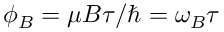Convert formula to latex. <formula><loc_0><loc_0><loc_500><loc_500>\phi _ { B } = \mu B \tau / \hbar { = } \omega _ { B } \tau</formula> 